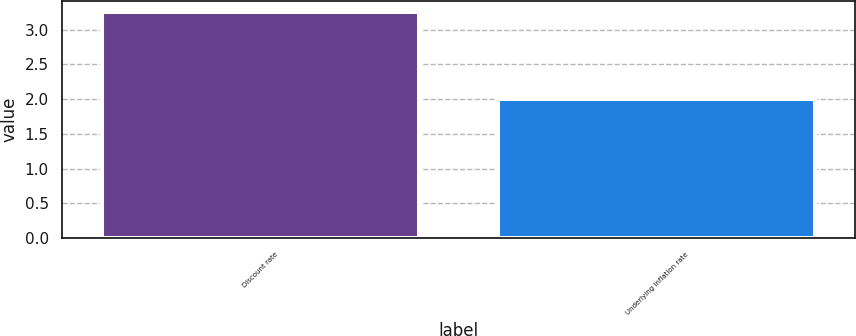Convert chart to OTSL. <chart><loc_0><loc_0><loc_500><loc_500><bar_chart><fcel>Discount rate<fcel>Underlying inflation rate<nl><fcel>3.25<fcel>2<nl></chart> 